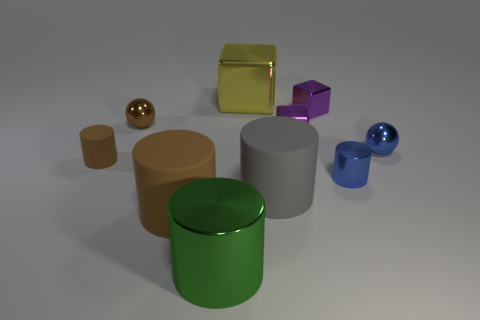Aside from their shapes and colors, do any of the objects share a common feature? Yes, several of the objects in the image share a reflective and shiny finish, which could indicate they are made from materials like metal or polished stone. This finish gives them a luxurious appeal and makes them stand out against the matte background. 